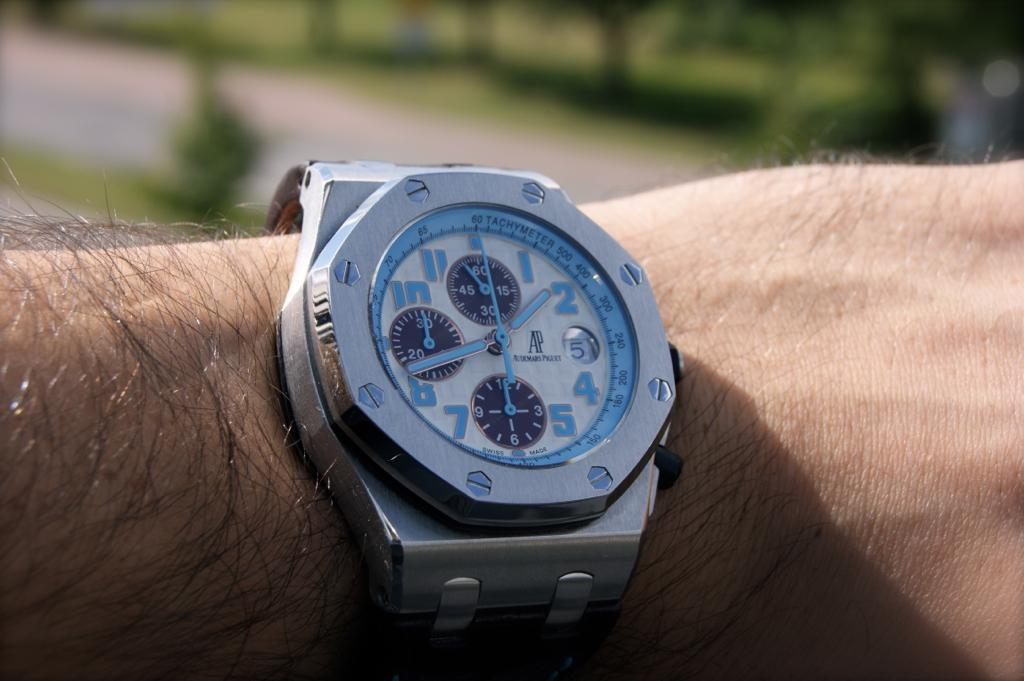Provide a one-sentence caption for the provided image. An AP brand watch has blue numbers and hands. 